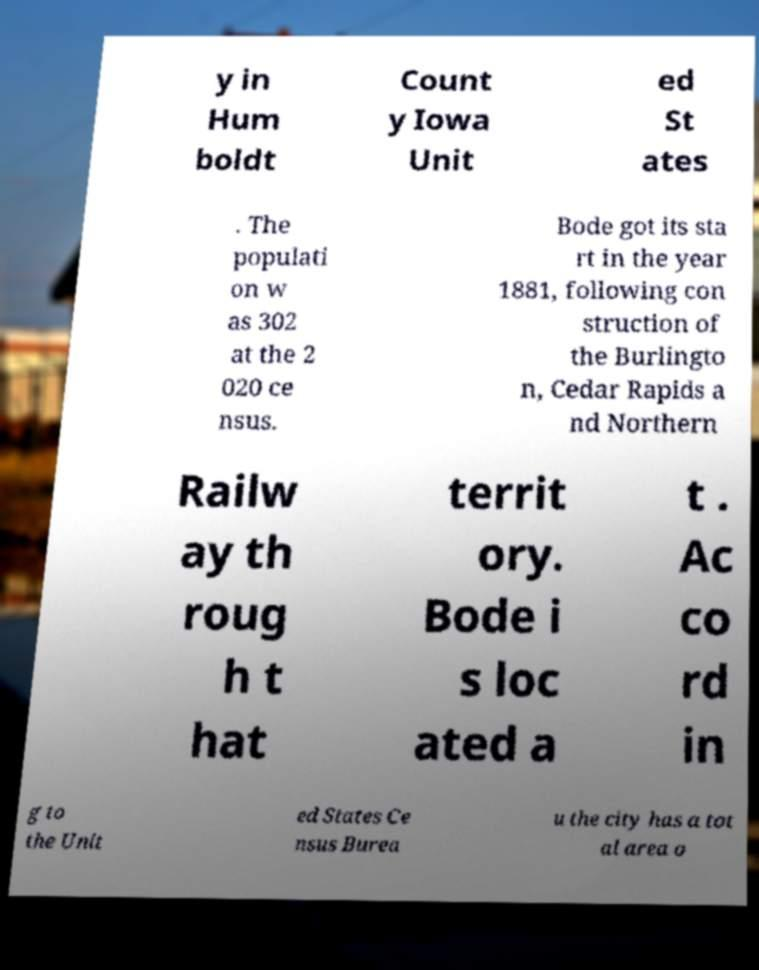Can you accurately transcribe the text from the provided image for me? y in Hum boldt Count y Iowa Unit ed St ates . The populati on w as 302 at the 2 020 ce nsus. Bode got its sta rt in the year 1881, following con struction of the Burlingto n, Cedar Rapids a nd Northern Railw ay th roug h t hat territ ory. Bode i s loc ated a t . Ac co rd in g to the Unit ed States Ce nsus Burea u the city has a tot al area o 